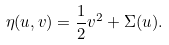Convert formula to latex. <formula><loc_0><loc_0><loc_500><loc_500>\eta ( u , v ) = \frac { 1 } { 2 } v ^ { 2 } + \Sigma ( u ) .</formula> 